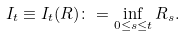Convert formula to latex. <formula><loc_0><loc_0><loc_500><loc_500>I _ { t } \equiv I _ { t } ( R ) \colon = \inf _ { 0 \leq s \leq t } R _ { s } .</formula> 